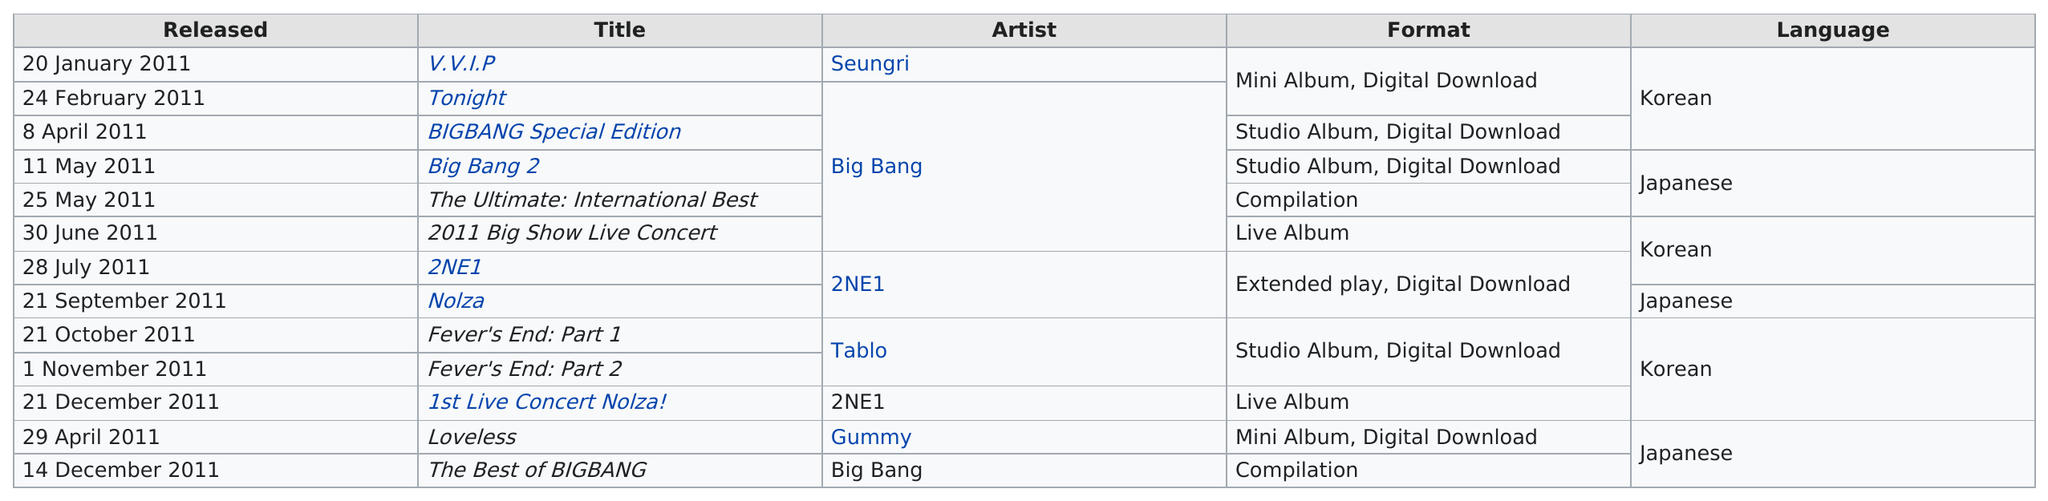Draw attention to some important aspects in this diagram. The Big Bang 2 was recorded in Japanese or Korean. In May, a certain number of songs was released. The exact number is two. The artist who released the last album in 2011 is Big Bang. In 2011, YG Entertainment released two compilation albums. The first live album that was released in 2011 is called 2011 Big Show Live Concert. 